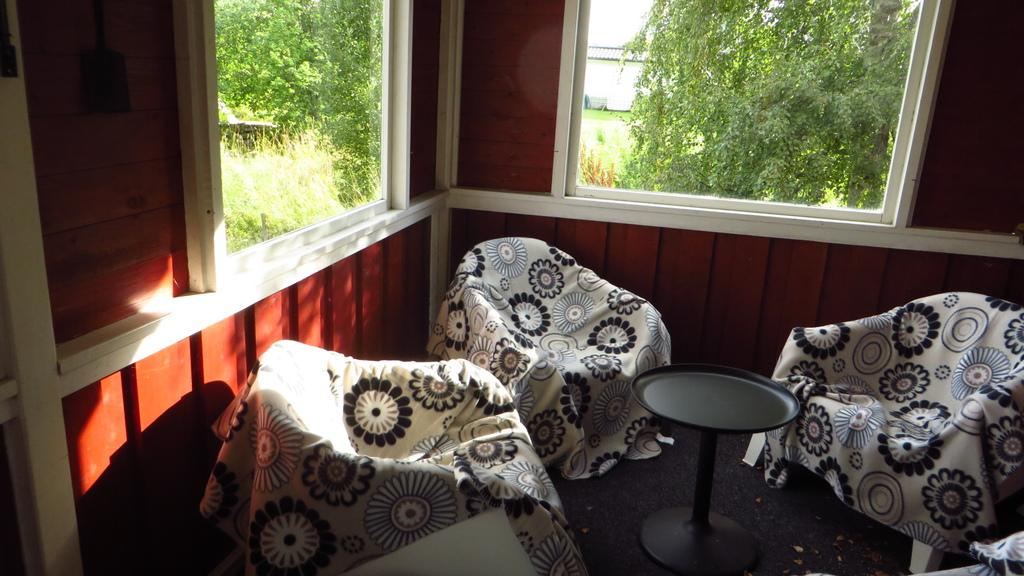What type of vehicles can be seen in the image? There are cars in the image. What else is present in the image besides cars? There are clothes and other objects visible in the image. What can be seen in the background of the image? There is a wall, a window, trees, and the sky visible in the background of the image. What is visible through the window in the image? Trees and the sky are visible through the window, along with other objects. What is the weight of the stamp on the car in the image? There is no stamp present on the car in the image, so it is not possible to determine its weight. 